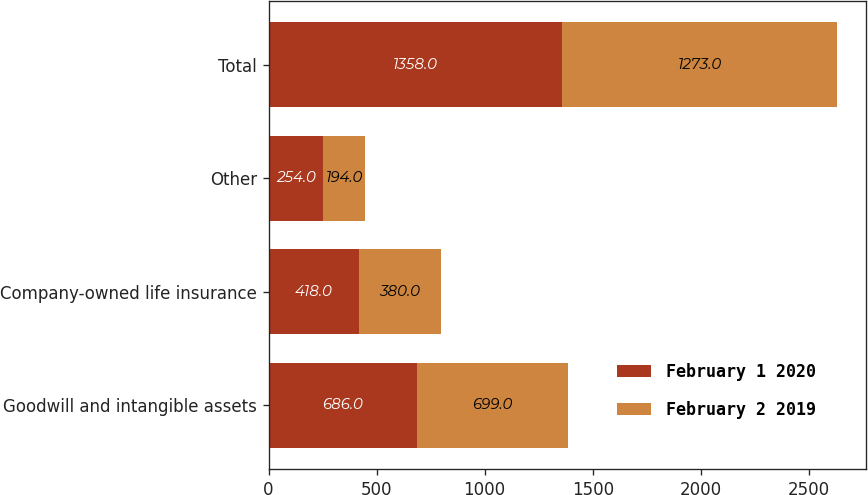Convert chart. <chart><loc_0><loc_0><loc_500><loc_500><stacked_bar_chart><ecel><fcel>Goodwill and intangible assets<fcel>Company-owned life insurance<fcel>Other<fcel>Total<nl><fcel>February 1 2020<fcel>686<fcel>418<fcel>254<fcel>1358<nl><fcel>February 2 2019<fcel>699<fcel>380<fcel>194<fcel>1273<nl></chart> 